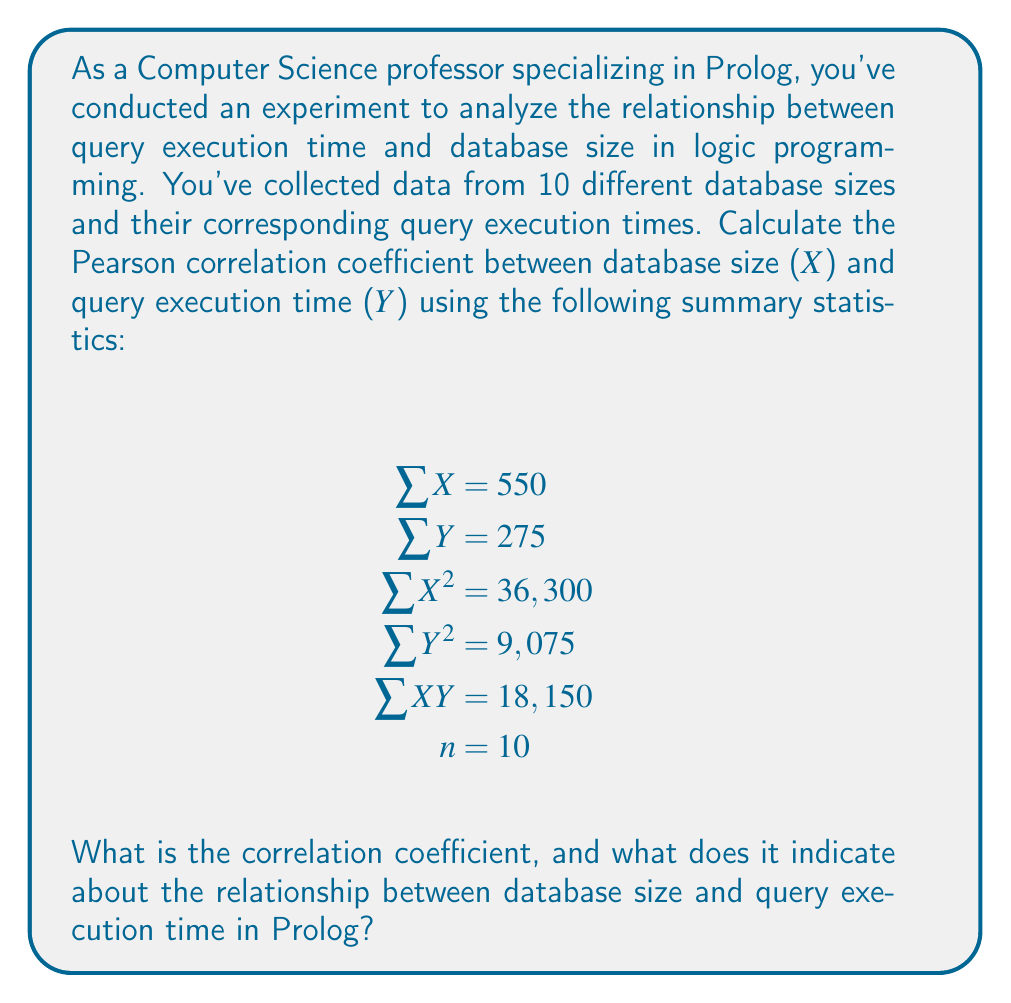Help me with this question. To calculate the Pearson correlation coefficient (r), we'll use the formula:

$$r = \frac{n\sum XY - (\sum X)(\sum Y)}{\sqrt{[n\sum X^2 - (\sum X)^2][n\sum Y^2 - (\sum Y)^2]}}$$

Let's substitute the given values and solve step by step:

1) Calculate $n\sum XY$:
   $10 \times 18,150 = 181,500$

2) Calculate $(\sum X)(\sum Y)$:
   $550 \times 275 = 151,250$

3) Calculate the numerator:
   $181,500 - 151,250 = 30,250$

4) For the denominator, first calculate:
   $n\sum X^2 = 10 \times 36,300 = 363,000$
   $(\sum X)^2 = 550^2 = 302,500$
   $n\sum Y^2 = 10 \times 9,075 = 90,750$
   $(\sum Y)^2 = 275^2 = 75,625$

5) Complete the denominator calculation:
   $\sqrt{(363,000 - 302,500)(90,750 - 75,625)}$
   $= \sqrt{60,500 \times 15,125}$
   $= \sqrt{915,062,500}$
   $= 30,250$

6) Final calculation:
   $r = \frac{30,250}{30,250} = 1$

The correlation coefficient is 1, indicating a perfect positive linear relationship between database size and query execution time in this Prolog experiment. This suggests that as the database size increases, the query execution time increases proportionally.
Answer: $r = 1$ (perfect positive correlation) 